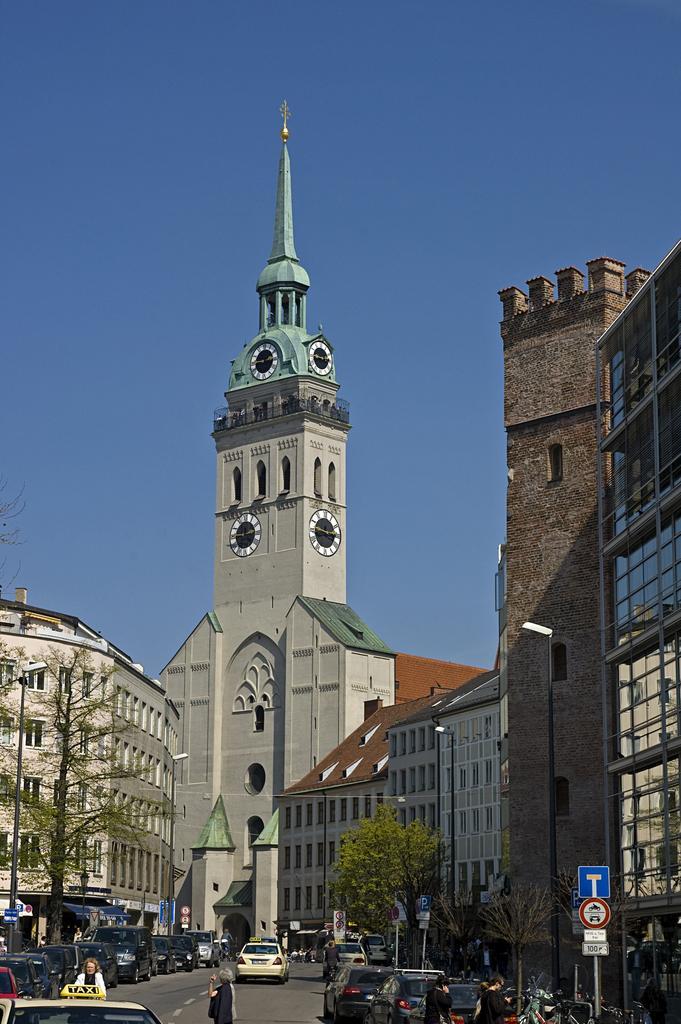Please provide a concise description of this image. In this image I can see few vehicles on the road, background I can see trees in green color, few sign boards, a clock tower, few buildings in gray, brown color and the sky is in blue color. 